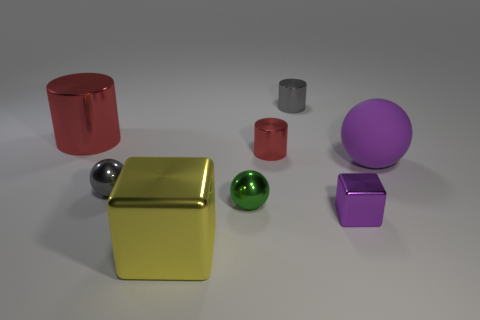Subtract all small metal balls. How many balls are left? 1 Subtract all gray spheres. How many spheres are left? 2 Add 1 yellow balls. How many objects exist? 9 Subtract all spheres. How many objects are left? 5 Subtract 2 spheres. How many spheres are left? 1 Subtract all brown cylinders. Subtract all brown blocks. How many cylinders are left? 3 Subtract all green spheres. How many green cubes are left? 0 Subtract all large cylinders. Subtract all large purple rubber spheres. How many objects are left? 6 Add 2 tiny spheres. How many tiny spheres are left? 4 Add 4 yellow shiny things. How many yellow shiny things exist? 5 